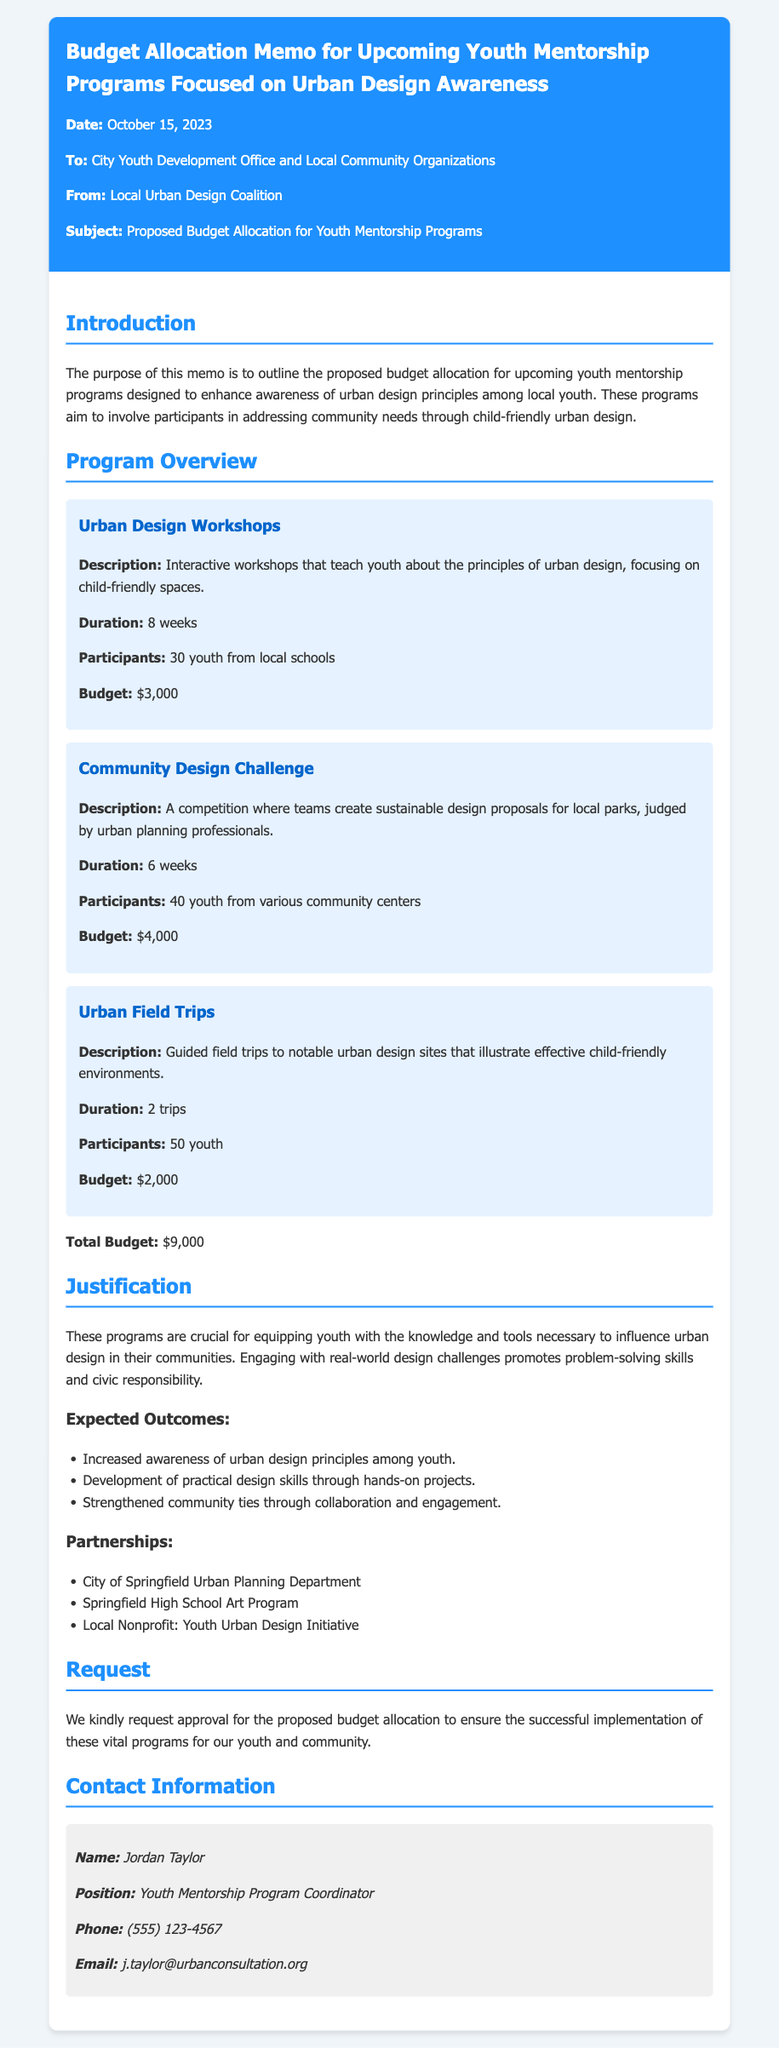what is the date of the memo? The date is indicated at the beginning of the document as October 15, 2023.
Answer: October 15, 2023 who is the sender of the memo? The sender is specified in the "From" section of the memo as the Local Urban Design Coalition.
Answer: Local Urban Design Coalition what is the total budget for the programs? The total budget is mentioned at the end of the program overview section as $9,000.
Answer: $9,000 how many youth will participate in the Urban Design Workshops? The number of participants for the Urban Design Workshops is stated as 30 youth from local schools.
Answer: 30 youth what are the expected outcomes listed in the memo? The expected outcomes are detailed in a bulleted list under the justification section.
Answer: Increased awareness of urban design principles among youth, Development of practical design skills through hands-on projects, Strengthened community ties through collaboration and engagement what is the duration of the Community Design Challenge? The duration is specified as 6 weeks within the program overview section.
Answer: 6 weeks which organization is listed as a partner in the programs? Partner organizations are outlined in the relevant section, with one being the City of Springfield Urban Planning Department.
Answer: City of Springfield Urban Planning Department who do you contact for more information? The contact information provided includes the name and position of Jordan Taylor, Youth Mentorship Program Coordinator.
Answer: Jordan Taylor, Youth Mentorship Program Coordinator what is the main purpose of these mentorship programs? The memo outlines that the main purpose is to enhance awareness of urban design principles among local youth.
Answer: Enhance awareness of urban design principles among local youth 